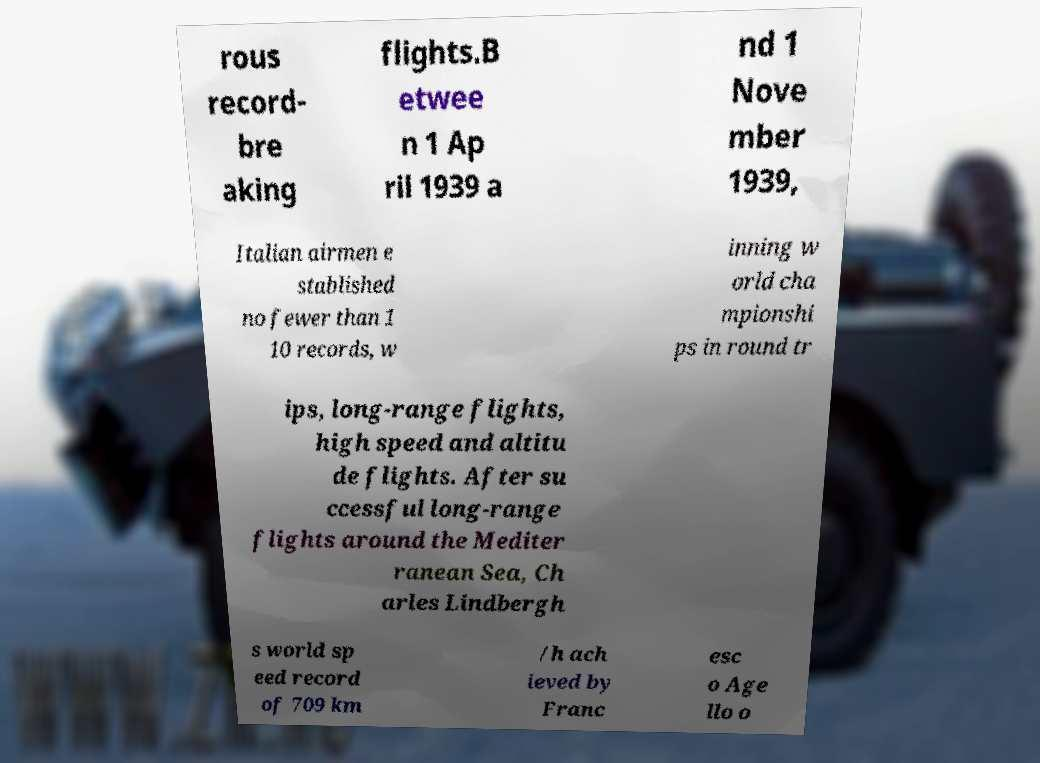Please identify and transcribe the text found in this image. rous record- bre aking flights.B etwee n 1 Ap ril 1939 a nd 1 Nove mber 1939, Italian airmen e stablished no fewer than 1 10 records, w inning w orld cha mpionshi ps in round tr ips, long-range flights, high speed and altitu de flights. After su ccessful long-range flights around the Mediter ranean Sea, Ch arles Lindbergh s world sp eed record of 709 km /h ach ieved by Franc esc o Age llo o 